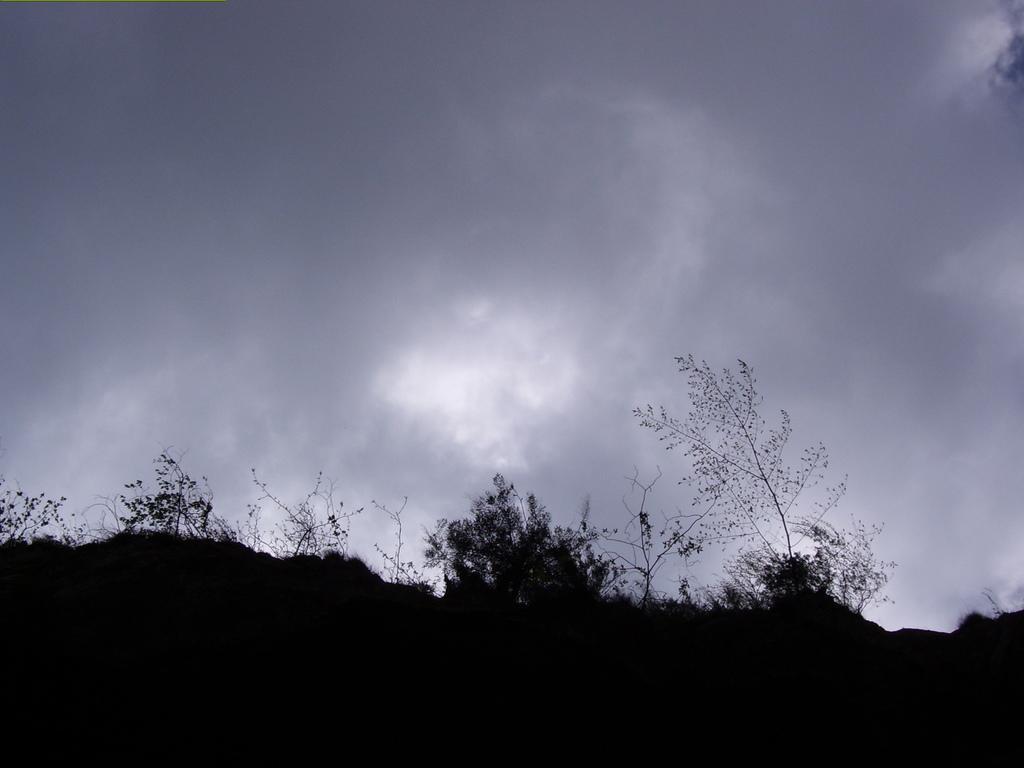Could you give a brief overview of what you see in this image? In this image we can see trees. In the background there is sky with clouds. 